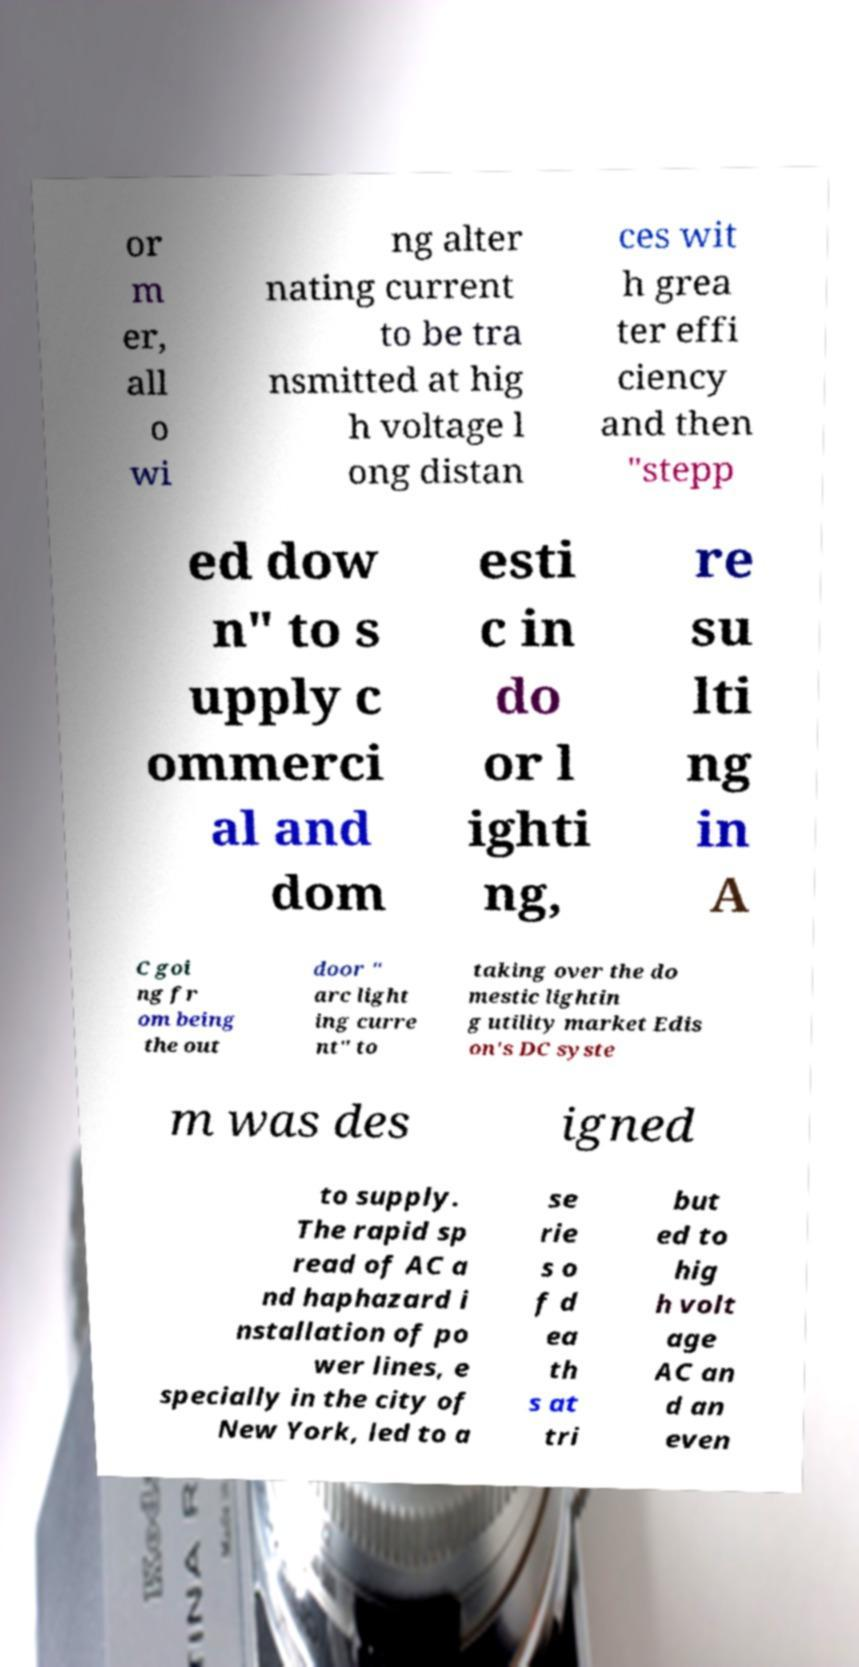For documentation purposes, I need the text within this image transcribed. Could you provide that? or m er, all o wi ng alter nating current to be tra nsmitted at hig h voltage l ong distan ces wit h grea ter effi ciency and then "stepp ed dow n" to s upply c ommerci al and dom esti c in do or l ighti ng, re su lti ng in A C goi ng fr om being the out door " arc light ing curre nt" to taking over the do mestic lightin g utility market Edis on's DC syste m was des igned to supply. The rapid sp read of AC a nd haphazard i nstallation of po wer lines, e specially in the city of New York, led to a se rie s o f d ea th s at tri but ed to hig h volt age AC an d an even 